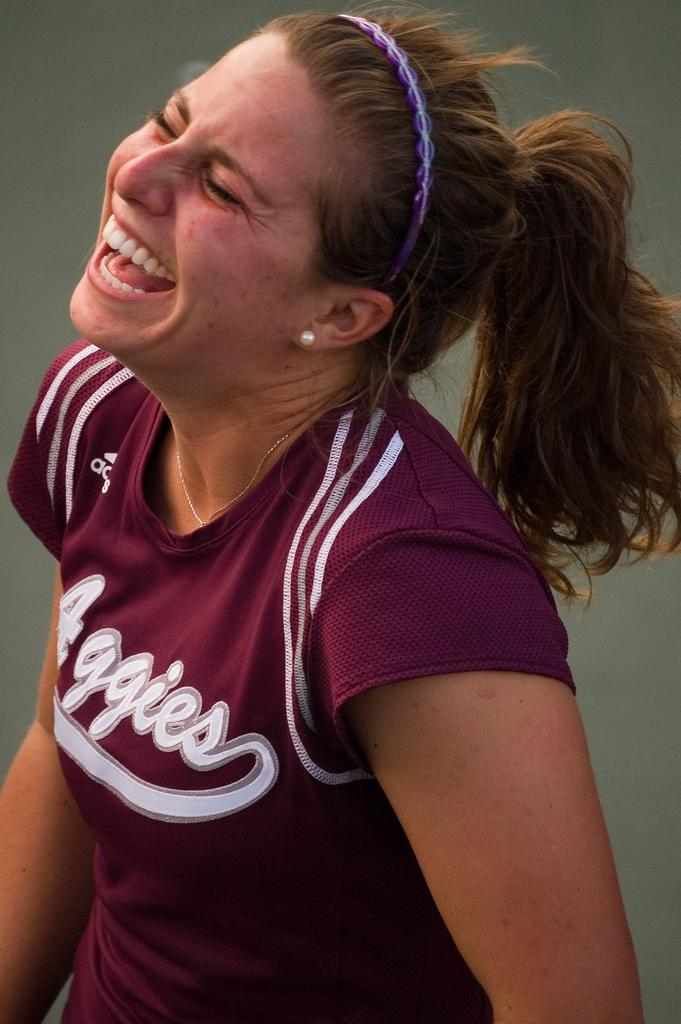Provide a one-sentence caption for the provided image. The woman with a purple head band is wearing a team jersey by Adidas. 